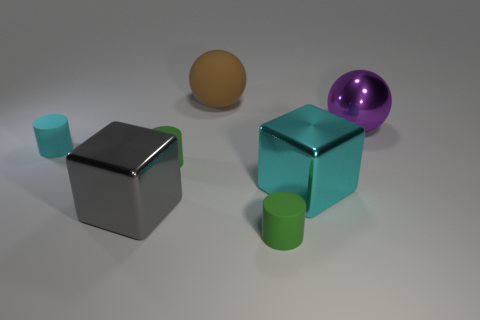Add 1 yellow blocks. How many objects exist? 8 Subtract all tiny green cylinders. How many cylinders are left? 1 Subtract all brown spheres. How many green cylinders are left? 2 Subtract all purple balls. How many balls are left? 1 Subtract all cylinders. How many objects are left? 4 Add 4 spheres. How many spheres exist? 6 Subtract 0 red cylinders. How many objects are left? 7 Subtract 2 balls. How many balls are left? 0 Subtract all brown spheres. Subtract all cyan cylinders. How many spheres are left? 1 Subtract all blue shiny cylinders. Subtract all cyan objects. How many objects are left? 5 